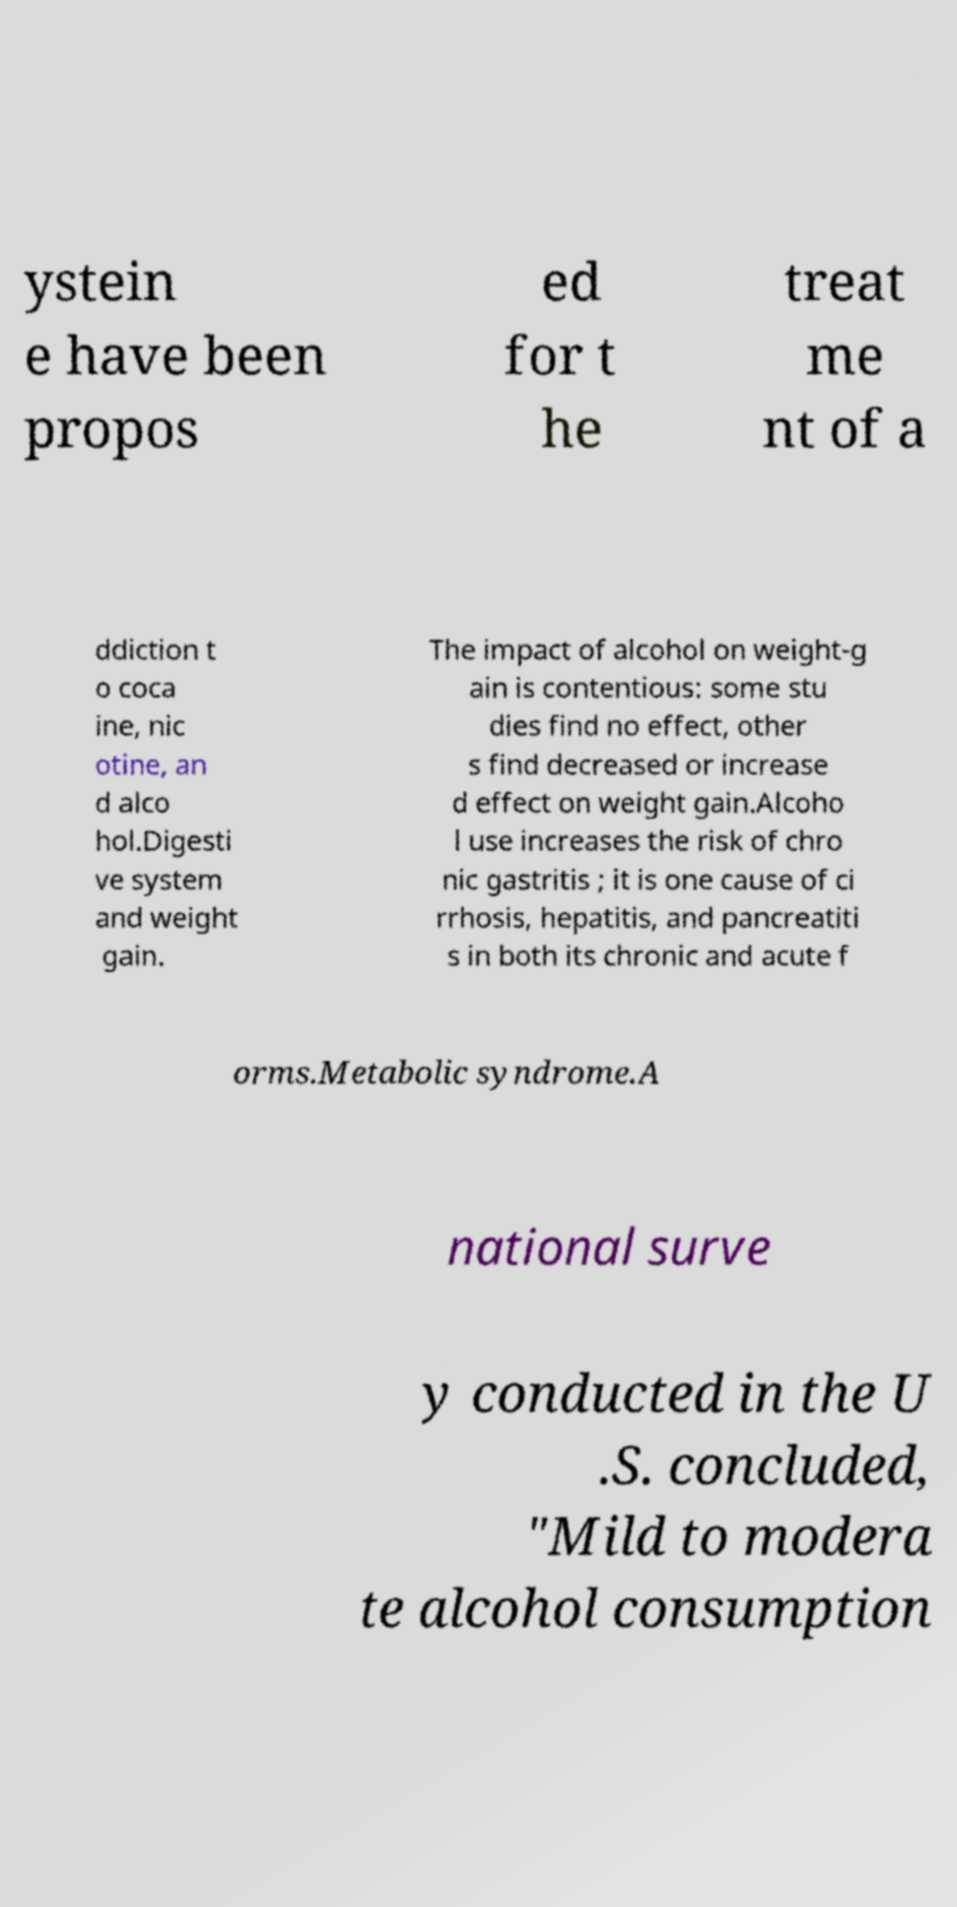Could you extract and type out the text from this image? ystein e have been propos ed for t he treat me nt of a ddiction t o coca ine, nic otine, an d alco hol.Digesti ve system and weight gain. The impact of alcohol on weight-g ain is contentious: some stu dies find no effect, other s find decreased or increase d effect on weight gain.Alcoho l use increases the risk of chro nic gastritis ; it is one cause of ci rrhosis, hepatitis, and pancreatiti s in both its chronic and acute f orms.Metabolic syndrome.A national surve y conducted in the U .S. concluded, "Mild to modera te alcohol consumption 